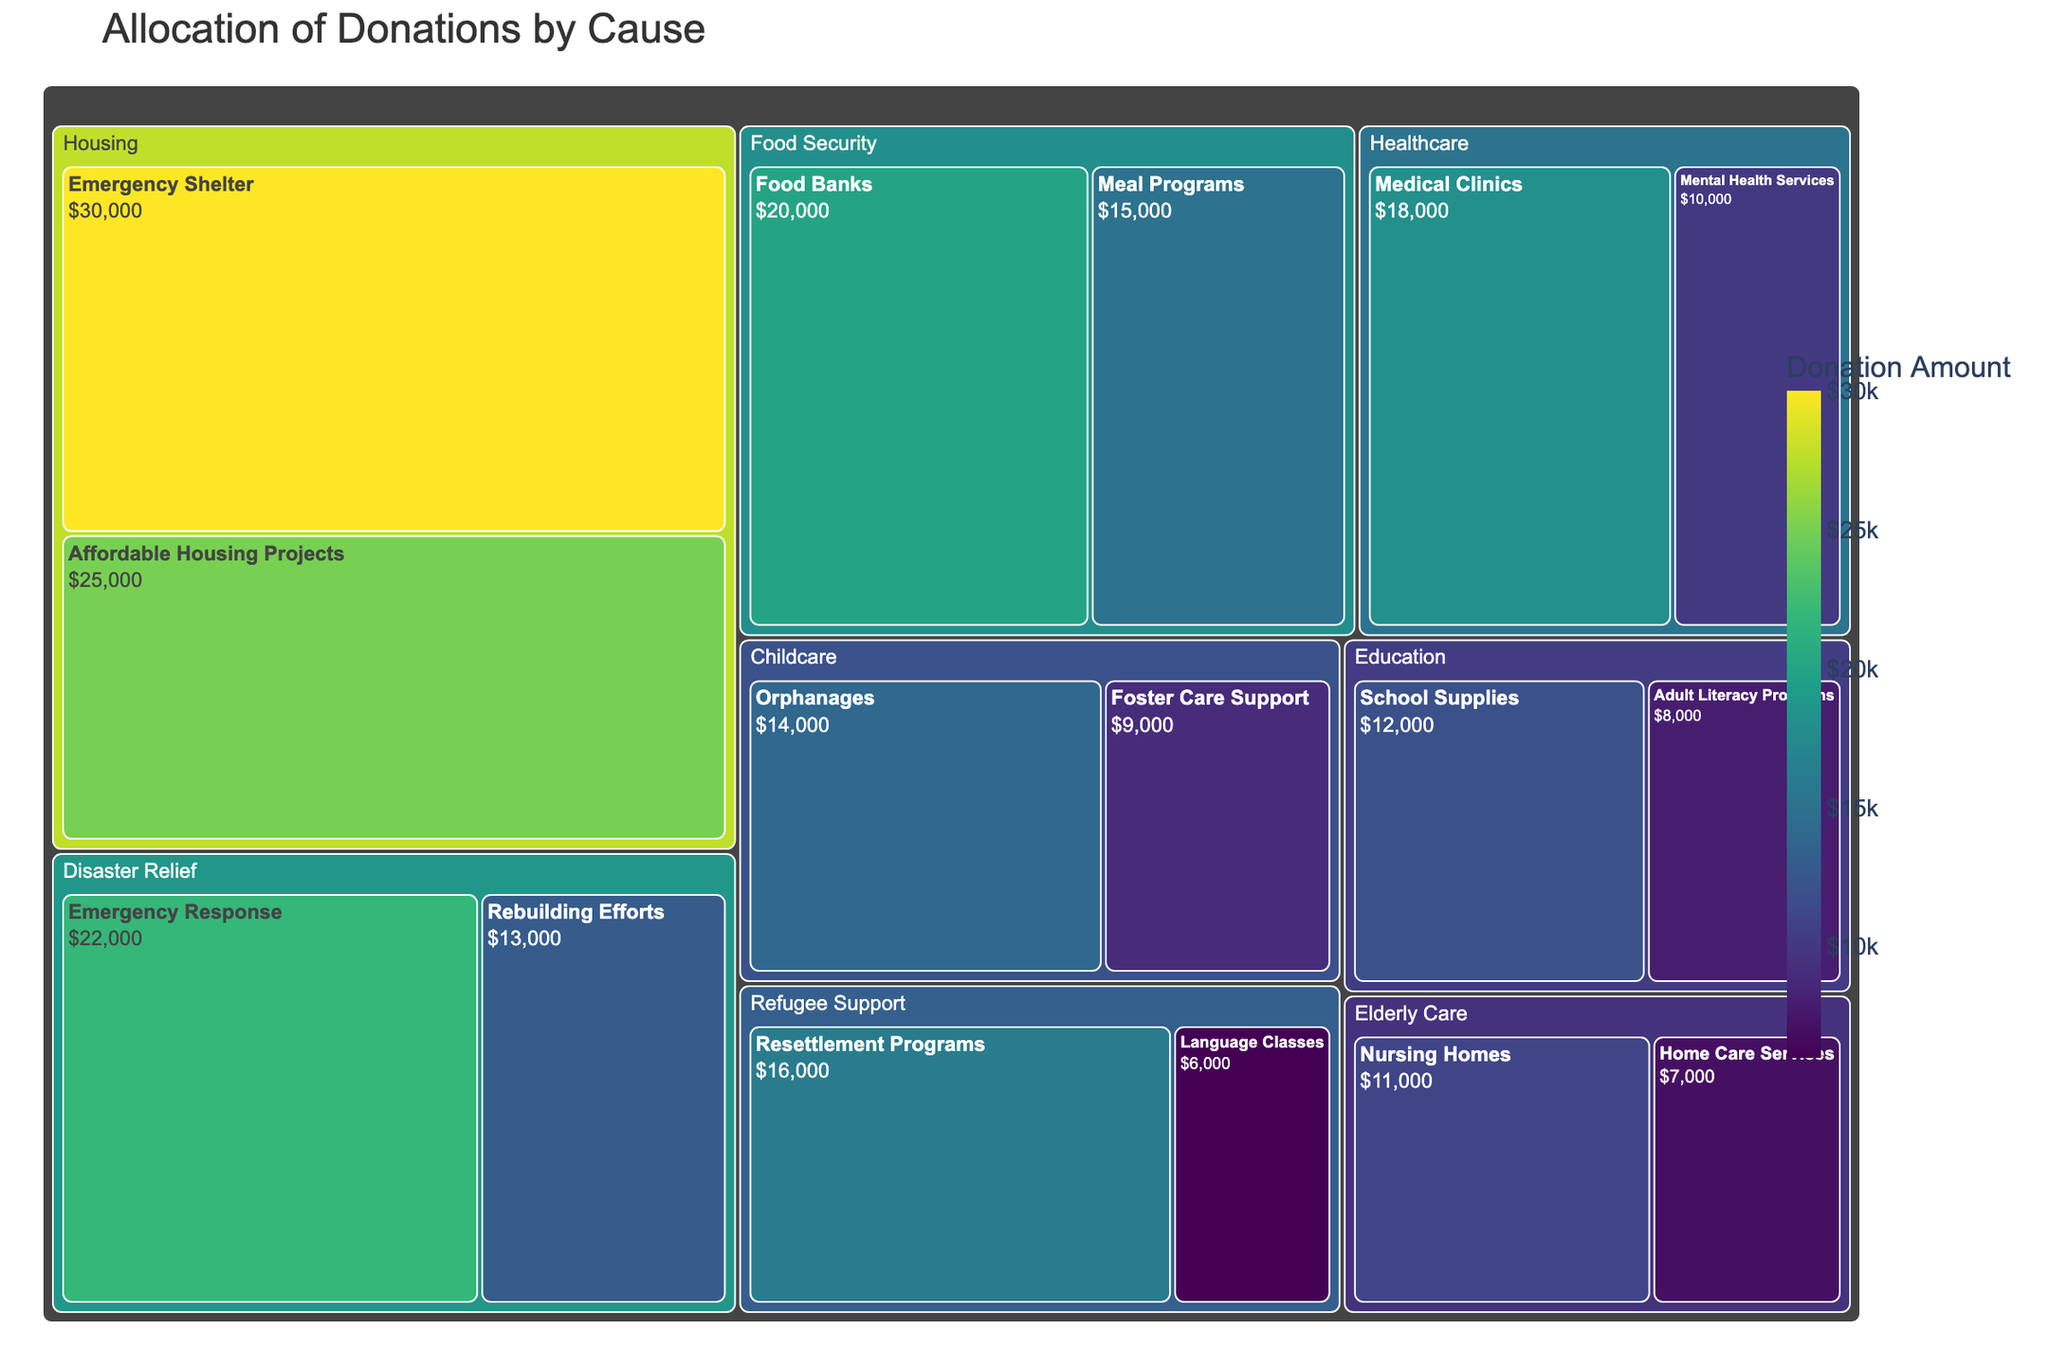Which category received the highest amount of donations? By looking at the Treemap, the largest block, indicating the highest donation amount among the categories, is the Housing category which includes subcategories receiving large allocations. This can be identified by its relative size compared to other categories.
Answer: Housing What is the total amount donated to Food Security? To find the total amount for Food Security, sum the values of its subcategories: Food Banks ($20,000) and Meal Programs ($15,000). So, $20,000 + $15,000 = $35,000.
Answer: $35,000 Which subcategory received more donations: Orphanages or Foster Care Support? By comparing the sizes of the blocks under the Childcare category, Orphanages received $14,000 while Foster Care Support received $9,000. Since $14,000 is greater than $9,000, Orphanages received more.
Answer: Orphanages How does the allocation to Emergency Response compare to Affordable Housing Projects? Comparing the values: Emergency Response under Disaster Relief received $22,000 whereas Affordable Housing Projects under Housing received $25,000. Since $22,000 is less than $25,000, Affordable Housing Projects received more.
Answer: Affordable Housing Projects What's the total amount donated to Healthcare? To find the total, sum the values of subcategories under Healthcare: Medical Clinics ($18,000) and Mental Health Services ($10,000). So, $18,000 + $10,000 = $28,000.
Answer: $28,000 Which category has the smallest overall donation, and what is the amount? By examining the relative sizes of the categories, Elderly Care appears the smallest with donations to Nursing Homes ($11,000) and Home Care Services ($7,000), totaling $18,000.
Answer: Elderly Care, $18,000 Which received more donations: Resettlement Programs or Rebuilding Efforts? Under Refugee Support, Resettlement Programs received $16,000. Under Disaster Relief, Rebuilding Efforts received $13,000. Since $16,000 is greater than $13,000, Resettlement Programs received more.
Answer: Resettlement Programs What is the average donation amount for Education subcategories? To find the average, sum the donations for Education subcategories: School Supplies ($12,000) and Adult Literacy Programs ($8,000) which total $20,000. Then, divide by the number of subcategories: $20,000 / 2 = $10,000.
Answer: $10,000 How much more was donated to Housing compared to Childcare? Sum the donations for Housing: Emergency Shelter ($30,000) and Affordable Housing Projects ($25,000) totaling $55,000. Sum the donations for Childcare: Orphanages ($14,000) and Foster Care Support ($9,000) totaling $23,000. The difference is $55,000 - $23,000 = $32,000.
Answer: $32,000 